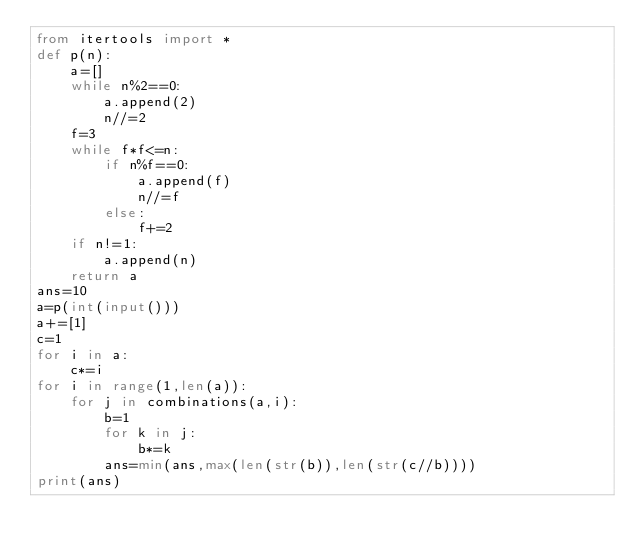<code> <loc_0><loc_0><loc_500><loc_500><_Python_>from itertools import *
def p(n):
    a=[]
    while n%2==0:
        a.append(2)
        n//=2
    f=3
    while f*f<=n:
        if n%f==0:
            a.append(f)
            n//=f
        else:
            f+=2
    if n!=1:
        a.append(n)
    return a
ans=10
a=p(int(input()))
a+=[1]   
c=1
for i in a:
    c*=i
for i in range(1,len(a)):
    for j in combinations(a,i):
        b=1
        for k in j:
            b*=k
        ans=min(ans,max(len(str(b)),len(str(c//b))))
print(ans)</code> 